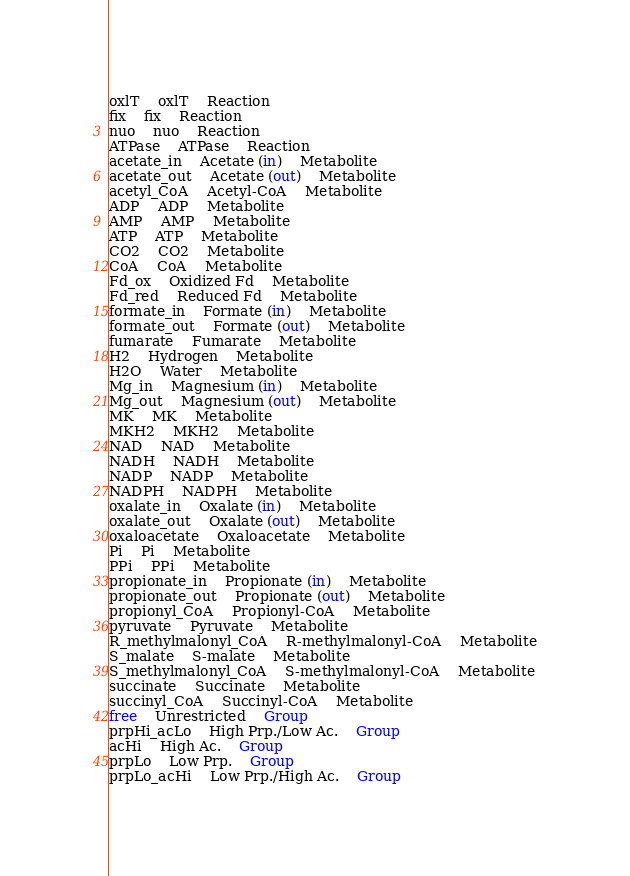Convert code to text. <code><loc_0><loc_0><loc_500><loc_500><_SQL_>oxlT	oxlT	Reaction
fix	fix	Reaction
nuo	nuo	Reaction
ATPase	ATPase	Reaction
acetate_in	Acetate (in)	Metabolite
acetate_out	Acetate (out)	Metabolite
acetyl_CoA	Acetyl-CoA	Metabolite
ADP	ADP	Metabolite
AMP	AMP	Metabolite
ATP	ATP	Metabolite
CO2	CO2	Metabolite
CoA	CoA	Metabolite
Fd_ox	Oxidized Fd	Metabolite
Fd_red	Reduced Fd	Metabolite
formate_in	Formate (in)	Metabolite
formate_out	Formate (out)	Metabolite
fumarate	Fumarate	Metabolite
H2	Hydrogen	Metabolite
H2O	Water	Metabolite
Mg_in	Magnesium (in)	Metabolite
Mg_out	Magnesium (out)	Metabolite
MK	MK	Metabolite
MKH2	MKH2	Metabolite
NAD	NAD	Metabolite
NADH	NADH	Metabolite
NADP	NADP	Metabolite
NADPH	NADPH	Metabolite
oxalate_in	Oxalate (in)	Metabolite
oxalate_out	Oxalate (out)	Metabolite
oxaloacetate	Oxaloacetate	Metabolite
Pi	Pi	Metabolite
PPi	PPi	Metabolite
propionate_in	Propionate (in)	Metabolite
propionate_out	Propionate (out)	Metabolite
propionyl_CoA	Propionyl-CoA	Metabolite
pyruvate	Pyruvate	Metabolite
R_methylmalonyl_CoA	R-methylmalonyl-CoA	Metabolite
S_malate	S-malate	Metabolite
S_methylmalonyl_CoA	S-methylmalonyl-CoA	Metabolite
succinate	Succinate	Metabolite
succinyl_CoA	Succinyl-CoA	Metabolite
free	Unrestricted	Group
prpHi_acLo	High Prp./Low Ac.	Group
acHi	High Ac.	Group
prpLo	Low Prp.	Group
prpLo_acHi	Low Prp./High Ac.	Group
</code> 